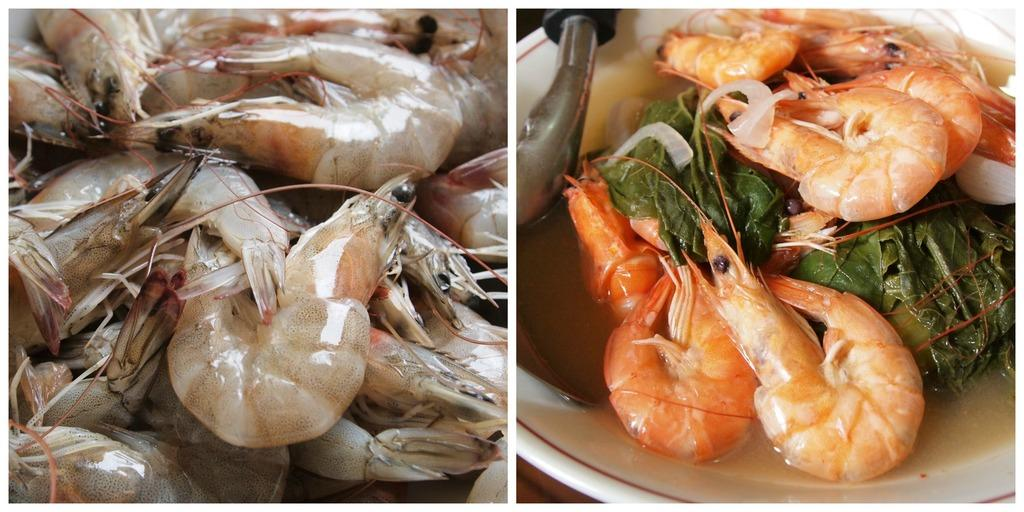What type of artwork is depicted in the image? The image is a collage. What is the main subject of the collage? The collage consists of prawns. What type of bomb is hidden within the collage? There is no bomb present in the collage; it consists solely of prawns. 